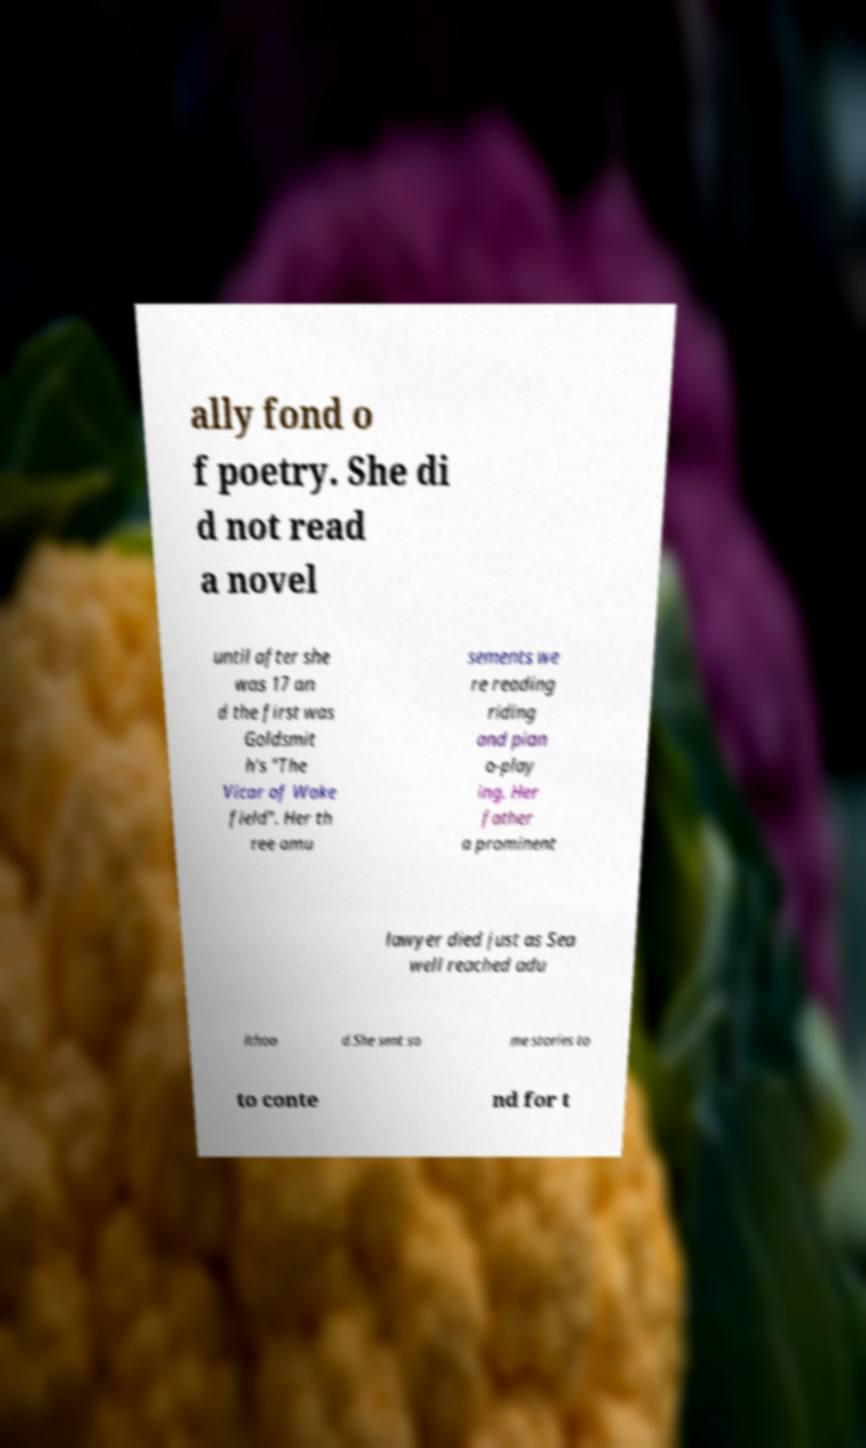Can you accurately transcribe the text from the provided image for me? ally fond o f poetry. She di d not read a novel until after she was 17 an d the first was Goldsmit h's "The Vicar of Wake field". Her th ree amu sements we re reading riding and pian o-play ing. Her father a prominent lawyer died just as Sea well reached adu lthoo d.She sent so me stories to to conte nd for t 